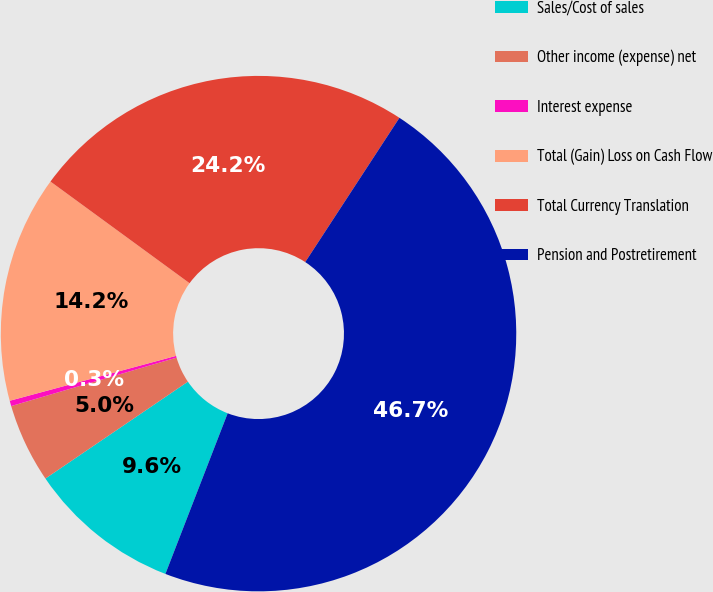<chart> <loc_0><loc_0><loc_500><loc_500><pie_chart><fcel>Sales/Cost of sales<fcel>Other income (expense) net<fcel>Interest expense<fcel>Total (Gain) Loss on Cash Flow<fcel>Total Currency Translation<fcel>Pension and Postretirement<nl><fcel>9.61%<fcel>4.97%<fcel>0.34%<fcel>14.24%<fcel>24.16%<fcel>46.68%<nl></chart> 